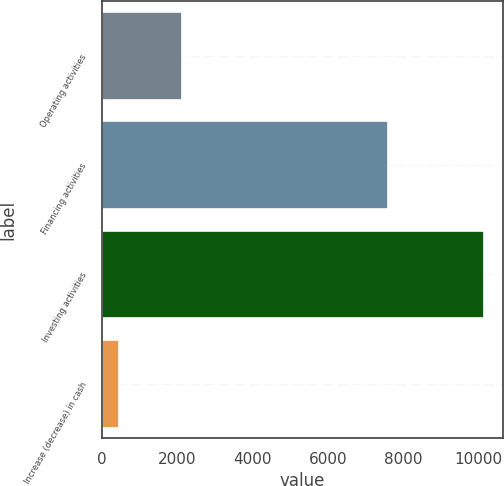Convert chart. <chart><loc_0><loc_0><loc_500><loc_500><bar_chart><fcel>Operating activities<fcel>Financing activities<fcel>Investing activities<fcel>Increase (decrease) in cash<nl><fcel>2115<fcel>7601<fcel>10157<fcel>441<nl></chart> 